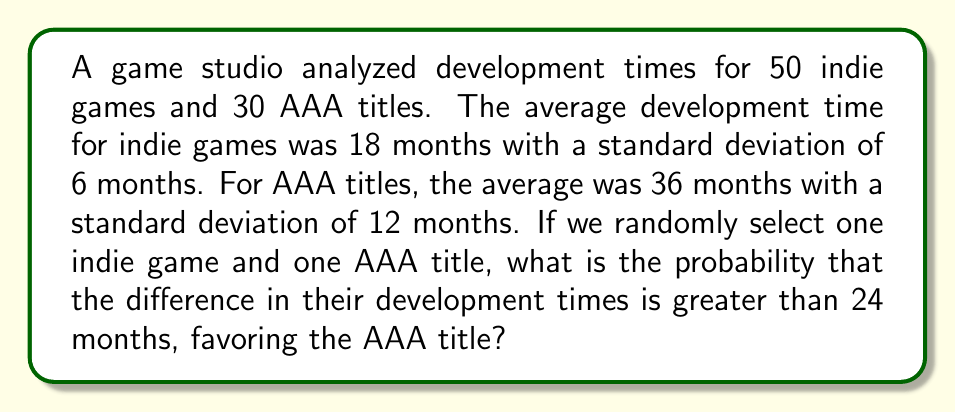Provide a solution to this math problem. Let's approach this step-by-step:

1) Let $X$ be the development time for an indie game and $Y$ be the development time for a AAA title.

2) We're interested in $P(Y - X > 24)$

3) We know:
   $X \sim N(\mu_X = 18, \sigma_X = 6)$
   $Y \sim N(\mu_Y = 36, \sigma_Y = 12)$

4) $Y - X$ follows a normal distribution with:
   $\mu_{Y-X} = \mu_Y - \mu_X = 36 - 18 = 18$
   $\sigma_{Y-X} = \sqrt{\sigma_Y^2 + \sigma_X^2} = \sqrt{12^2 + 6^2} = \sqrt{180} = 6\sqrt{5}$

5) We need to find $P(Y - X > 24)$, which is equivalent to:

   $$P\left(\frac{Y - X - \mu_{Y-X}}{\sigma_{Y-X}} > \frac{24 - \mu_{Y-X}}{\sigma_{Y-X}}\right)$$

6) Calculating the Z-score:
   $$Z = \frac{24 - 18}{6\sqrt{5}} = \frac{1}{\sqrt{5}} \approx 0.4472$$

7) We need to find $P(Z > 0.4472)$
   Using a standard normal table or calculator, we get:
   $P(Z > 0.4472) \approx 0.3274$

Therefore, the probability that the difference in development times is greater than 24 months, favoring the AAA title, is approximately 0.3274 or 32.74%.
Answer: 0.3274 